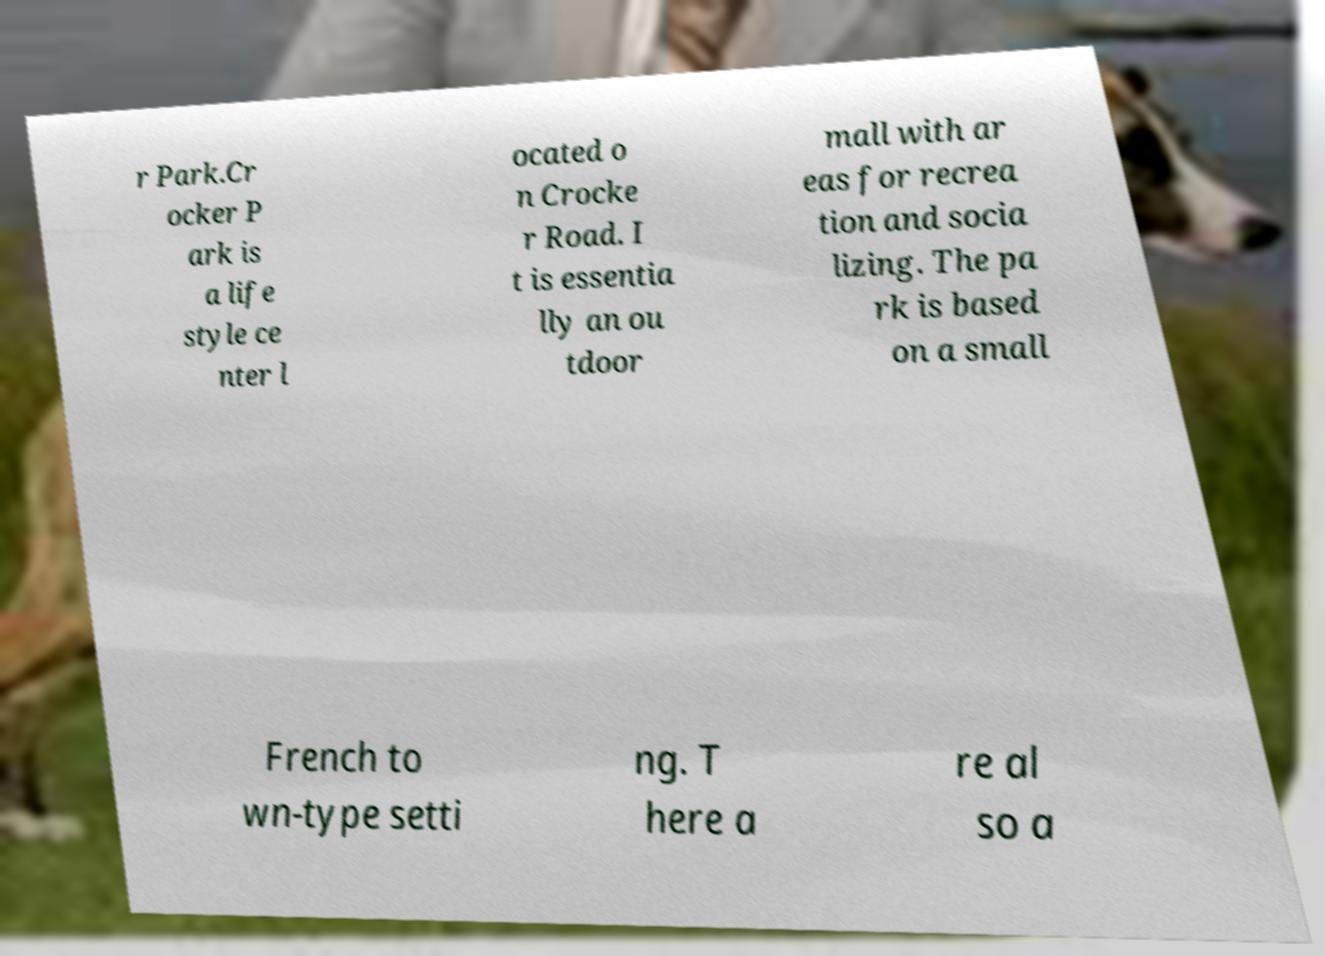Could you extract and type out the text from this image? r Park.Cr ocker P ark is a life style ce nter l ocated o n Crocke r Road. I t is essentia lly an ou tdoor mall with ar eas for recrea tion and socia lizing. The pa rk is based on a small French to wn-type setti ng. T here a re al so a 